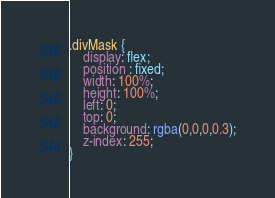Convert code to text. <code><loc_0><loc_0><loc_500><loc_500><_CSS_>.divMask {
    display: flex;
    position : fixed;
    width: 100%;
    height: 100%;
    left: 0;
    top: 0;
    background: rgba(0,0,0,0.3);
    z-index: 255;
}

</code> 